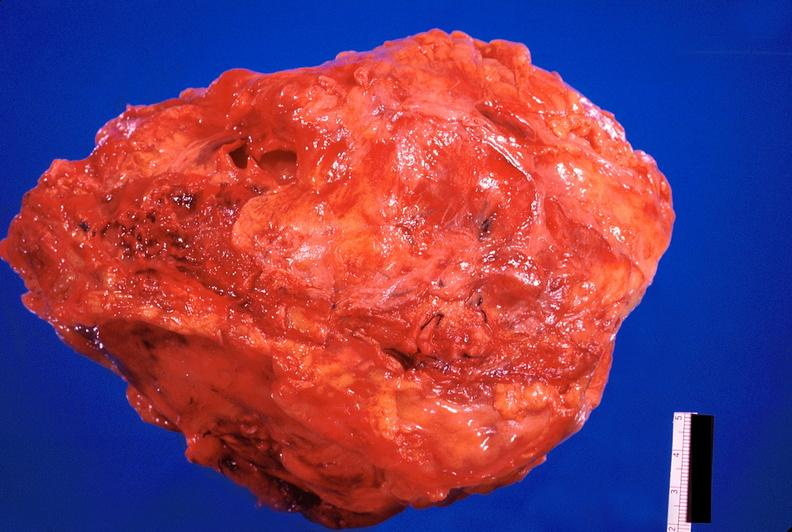where is this?
Answer the question using a single word or phrase. Heart 